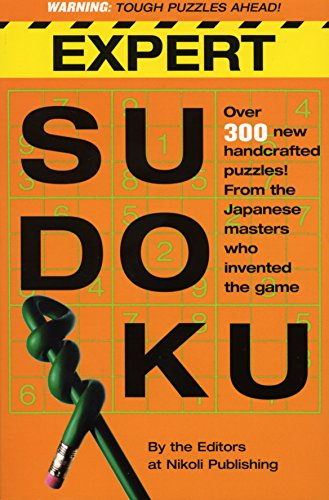Who is the author of this book? The book 'Expert Sudoku' is authored by Nikoli Publishing, a renowned Japanese publisher that originally popularized Sudoku puzzles. 